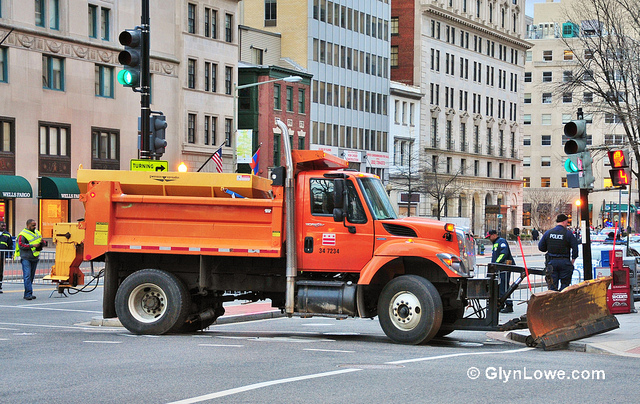What is the significance of the traffic lights in this context? The traffic lights in the image play a crucial role in maintaining order and safety at the intersection. They regulate the flow of vehicles and pedestrians, ensuring that traffic moves smoothly and preventing accidents. In the context of this image, the traffic lights are particularly important as they coordinate with the activities of the road maintenance crew. The controlled traffic flow allows the workers to perform their duties without interference from oncoming vehicles, enhancing safety for both the workers and the drivers. The presence of multiple traffic lights at different positions ensures comprehensive management of the intersection, highlighting the importance of organized traffic control in urban environments.  Do you think this image could be part of an art project exploring urban life? Absolutely! This image could be a compelling component of an art project that explores the dynamics of urban life. The juxtaposition of the bright orange truck against the backdrop of city buildings, coupled with the presence of traffic lights and workers, captures the essence of urban infrastructure and maintenance. It highlights the often-overlooked aspects of city living, such as the essential work carried out by maintenance crews to keep the urban environment functional. This image could evoke themes of cooperation, the relentless pace of city life, and the intricate machinery that operates behind the scenes. In the context of an art project, it could serve as a visual commentary on the efforts that go into maintaining and supporting the urban landscape that many take for granted. If this truck could talk, what stories might it tell? If this orange truck could talk, it would likely have a treasure trove of stories to share. It would recount the countless hours spent clearing snow during fierce winter storms, ensuring that the city streets remain passable. It might tell tales of early morning starts, navigating through deserted roads before the city wakes up, or of late nights under the streetlights, making urgent repairs to keep traffic flowing. The truck would speak of the camaraderie among the maintenance crew, the jokes shared during coffee breaks, and the pride felt in a job well done. It could also reveal encounters with curious passersby, children waving from sidewalks, and the gratitude of citizens during harsh weather. Through its tales, the truck would provide a unique perspective on the unseen efforts that go into keeping the city running smoothly, day in and day out. 